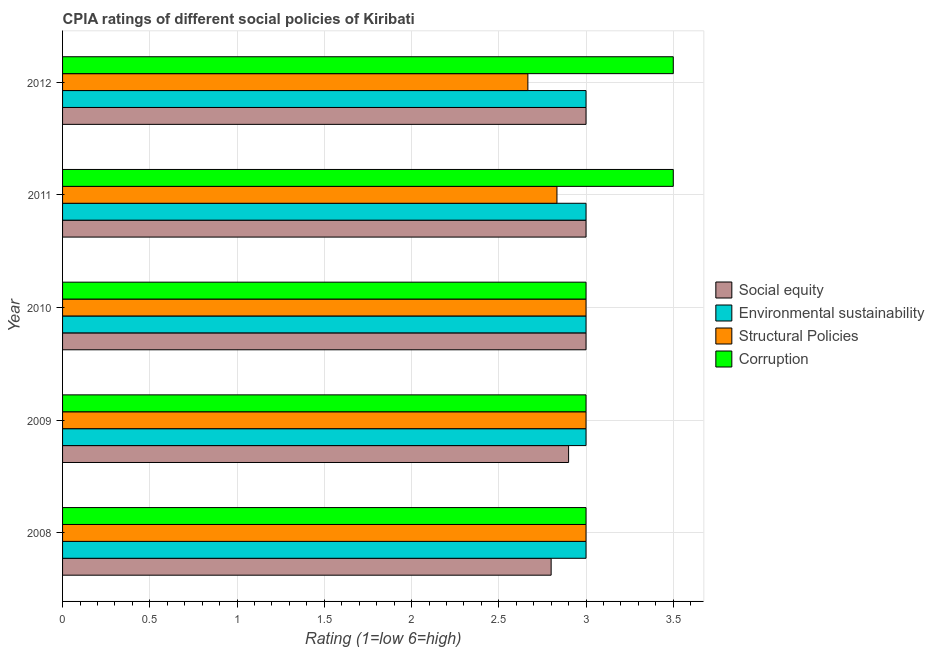How many different coloured bars are there?
Your response must be concise. 4. How many groups of bars are there?
Provide a succinct answer. 5. Are the number of bars per tick equal to the number of legend labels?
Keep it short and to the point. Yes. Are the number of bars on each tick of the Y-axis equal?
Provide a short and direct response. Yes. How many bars are there on the 2nd tick from the top?
Offer a terse response. 4. Across all years, what is the maximum cpia rating of environmental sustainability?
Your answer should be compact. 3. Across all years, what is the minimum cpia rating of structural policies?
Ensure brevity in your answer.  2.67. In which year was the cpia rating of structural policies maximum?
Provide a succinct answer. 2008. In which year was the cpia rating of corruption minimum?
Provide a short and direct response. 2008. What is the difference between the cpia rating of social equity in 2010 and the cpia rating of structural policies in 2009?
Ensure brevity in your answer.  0. In the year 2011, what is the difference between the cpia rating of environmental sustainability and cpia rating of structural policies?
Ensure brevity in your answer.  0.17. In how many years, is the cpia rating of social equity greater than 3.4 ?
Your answer should be compact. 0. What is the ratio of the cpia rating of social equity in 2009 to that in 2011?
Offer a very short reply. 0.97. Is the cpia rating of corruption in 2009 less than that in 2012?
Give a very brief answer. Yes. Is the difference between the cpia rating of structural policies in 2010 and 2012 greater than the difference between the cpia rating of corruption in 2010 and 2012?
Your answer should be compact. Yes. In how many years, is the cpia rating of corruption greater than the average cpia rating of corruption taken over all years?
Your answer should be very brief. 2. Is it the case that in every year, the sum of the cpia rating of environmental sustainability and cpia rating of structural policies is greater than the sum of cpia rating of corruption and cpia rating of social equity?
Make the answer very short. No. What does the 1st bar from the top in 2008 represents?
Offer a very short reply. Corruption. What does the 2nd bar from the bottom in 2012 represents?
Give a very brief answer. Environmental sustainability. Is it the case that in every year, the sum of the cpia rating of social equity and cpia rating of environmental sustainability is greater than the cpia rating of structural policies?
Offer a very short reply. Yes. How many bars are there?
Provide a short and direct response. 20. How many years are there in the graph?
Offer a terse response. 5. Are the values on the major ticks of X-axis written in scientific E-notation?
Offer a terse response. No. Where does the legend appear in the graph?
Give a very brief answer. Center right. What is the title of the graph?
Give a very brief answer. CPIA ratings of different social policies of Kiribati. Does "Services" appear as one of the legend labels in the graph?
Your answer should be compact. No. What is the label or title of the Y-axis?
Keep it short and to the point. Year. What is the Rating (1=low 6=high) in Environmental sustainability in 2008?
Offer a terse response. 3. What is the Rating (1=low 6=high) in Corruption in 2008?
Make the answer very short. 3. What is the Rating (1=low 6=high) of Social equity in 2009?
Provide a succinct answer. 2.9. What is the Rating (1=low 6=high) in Structural Policies in 2009?
Your response must be concise. 3. What is the Rating (1=low 6=high) in Corruption in 2009?
Keep it short and to the point. 3. What is the Rating (1=low 6=high) of Social equity in 2010?
Provide a succinct answer. 3. What is the Rating (1=low 6=high) in Structural Policies in 2010?
Provide a succinct answer. 3. What is the Rating (1=low 6=high) in Corruption in 2010?
Offer a terse response. 3. What is the Rating (1=low 6=high) in Social equity in 2011?
Give a very brief answer. 3. What is the Rating (1=low 6=high) in Structural Policies in 2011?
Provide a short and direct response. 2.83. What is the Rating (1=low 6=high) in Social equity in 2012?
Your response must be concise. 3. What is the Rating (1=low 6=high) in Structural Policies in 2012?
Offer a very short reply. 2.67. What is the Rating (1=low 6=high) of Corruption in 2012?
Your answer should be compact. 3.5. Across all years, what is the maximum Rating (1=low 6=high) of Social equity?
Provide a succinct answer. 3. Across all years, what is the maximum Rating (1=low 6=high) in Structural Policies?
Keep it short and to the point. 3. Across all years, what is the minimum Rating (1=low 6=high) in Social equity?
Your answer should be compact. 2.8. Across all years, what is the minimum Rating (1=low 6=high) in Structural Policies?
Your answer should be very brief. 2.67. Across all years, what is the minimum Rating (1=low 6=high) in Corruption?
Provide a short and direct response. 3. What is the total Rating (1=low 6=high) in Social equity in the graph?
Keep it short and to the point. 14.7. What is the total Rating (1=low 6=high) of Environmental sustainability in the graph?
Give a very brief answer. 15. What is the total Rating (1=low 6=high) in Corruption in the graph?
Ensure brevity in your answer.  16. What is the difference between the Rating (1=low 6=high) in Social equity in 2008 and that in 2009?
Provide a short and direct response. -0.1. What is the difference between the Rating (1=low 6=high) in Environmental sustainability in 2008 and that in 2009?
Provide a succinct answer. 0. What is the difference between the Rating (1=low 6=high) of Corruption in 2008 and that in 2009?
Your answer should be very brief. 0. What is the difference between the Rating (1=low 6=high) of Social equity in 2008 and that in 2010?
Offer a very short reply. -0.2. What is the difference between the Rating (1=low 6=high) in Social equity in 2008 and that in 2011?
Keep it short and to the point. -0.2. What is the difference between the Rating (1=low 6=high) of Structural Policies in 2008 and that in 2011?
Make the answer very short. 0.17. What is the difference between the Rating (1=low 6=high) in Corruption in 2008 and that in 2011?
Keep it short and to the point. -0.5. What is the difference between the Rating (1=low 6=high) in Environmental sustainability in 2008 and that in 2012?
Offer a very short reply. 0. What is the difference between the Rating (1=low 6=high) in Social equity in 2009 and that in 2010?
Offer a very short reply. -0.1. What is the difference between the Rating (1=low 6=high) of Environmental sustainability in 2009 and that in 2010?
Ensure brevity in your answer.  0. What is the difference between the Rating (1=low 6=high) in Structural Policies in 2009 and that in 2010?
Offer a terse response. 0. What is the difference between the Rating (1=low 6=high) of Structural Policies in 2009 and that in 2011?
Your response must be concise. 0.17. What is the difference between the Rating (1=low 6=high) of Social equity in 2009 and that in 2012?
Make the answer very short. -0.1. What is the difference between the Rating (1=low 6=high) in Social equity in 2010 and that in 2011?
Your answer should be compact. 0. What is the difference between the Rating (1=low 6=high) in Structural Policies in 2010 and that in 2011?
Make the answer very short. 0.17. What is the difference between the Rating (1=low 6=high) of Corruption in 2010 and that in 2011?
Give a very brief answer. -0.5. What is the difference between the Rating (1=low 6=high) of Environmental sustainability in 2010 and that in 2012?
Provide a short and direct response. 0. What is the difference between the Rating (1=low 6=high) in Corruption in 2010 and that in 2012?
Offer a terse response. -0.5. What is the difference between the Rating (1=low 6=high) in Corruption in 2011 and that in 2012?
Offer a terse response. 0. What is the difference between the Rating (1=low 6=high) of Social equity in 2008 and the Rating (1=low 6=high) of Structural Policies in 2009?
Keep it short and to the point. -0.2. What is the difference between the Rating (1=low 6=high) in Social equity in 2008 and the Rating (1=low 6=high) in Corruption in 2009?
Give a very brief answer. -0.2. What is the difference between the Rating (1=low 6=high) of Structural Policies in 2008 and the Rating (1=low 6=high) of Corruption in 2009?
Provide a succinct answer. 0. What is the difference between the Rating (1=low 6=high) in Social equity in 2008 and the Rating (1=low 6=high) in Environmental sustainability in 2010?
Your answer should be very brief. -0.2. What is the difference between the Rating (1=low 6=high) of Social equity in 2008 and the Rating (1=low 6=high) of Corruption in 2010?
Offer a terse response. -0.2. What is the difference between the Rating (1=low 6=high) in Environmental sustainability in 2008 and the Rating (1=low 6=high) in Structural Policies in 2010?
Make the answer very short. 0. What is the difference between the Rating (1=low 6=high) of Structural Policies in 2008 and the Rating (1=low 6=high) of Corruption in 2010?
Provide a short and direct response. 0. What is the difference between the Rating (1=low 6=high) of Social equity in 2008 and the Rating (1=low 6=high) of Environmental sustainability in 2011?
Make the answer very short. -0.2. What is the difference between the Rating (1=low 6=high) of Social equity in 2008 and the Rating (1=low 6=high) of Structural Policies in 2011?
Offer a very short reply. -0.03. What is the difference between the Rating (1=low 6=high) in Social equity in 2008 and the Rating (1=low 6=high) in Corruption in 2011?
Offer a terse response. -0.7. What is the difference between the Rating (1=low 6=high) in Environmental sustainability in 2008 and the Rating (1=low 6=high) in Structural Policies in 2011?
Make the answer very short. 0.17. What is the difference between the Rating (1=low 6=high) of Social equity in 2008 and the Rating (1=low 6=high) of Environmental sustainability in 2012?
Keep it short and to the point. -0.2. What is the difference between the Rating (1=low 6=high) of Social equity in 2008 and the Rating (1=low 6=high) of Structural Policies in 2012?
Ensure brevity in your answer.  0.13. What is the difference between the Rating (1=low 6=high) in Social equity in 2008 and the Rating (1=low 6=high) in Corruption in 2012?
Make the answer very short. -0.7. What is the difference between the Rating (1=low 6=high) of Structural Policies in 2008 and the Rating (1=low 6=high) of Corruption in 2012?
Offer a very short reply. -0.5. What is the difference between the Rating (1=low 6=high) in Social equity in 2009 and the Rating (1=low 6=high) in Environmental sustainability in 2010?
Make the answer very short. -0.1. What is the difference between the Rating (1=low 6=high) of Social equity in 2009 and the Rating (1=low 6=high) of Structural Policies in 2010?
Provide a succinct answer. -0.1. What is the difference between the Rating (1=low 6=high) of Social equity in 2009 and the Rating (1=low 6=high) of Corruption in 2010?
Offer a terse response. -0.1. What is the difference between the Rating (1=low 6=high) in Environmental sustainability in 2009 and the Rating (1=low 6=high) in Structural Policies in 2010?
Make the answer very short. 0. What is the difference between the Rating (1=low 6=high) of Social equity in 2009 and the Rating (1=low 6=high) of Environmental sustainability in 2011?
Ensure brevity in your answer.  -0.1. What is the difference between the Rating (1=low 6=high) of Social equity in 2009 and the Rating (1=low 6=high) of Structural Policies in 2011?
Keep it short and to the point. 0.07. What is the difference between the Rating (1=low 6=high) in Social equity in 2009 and the Rating (1=low 6=high) in Environmental sustainability in 2012?
Keep it short and to the point. -0.1. What is the difference between the Rating (1=low 6=high) of Social equity in 2009 and the Rating (1=low 6=high) of Structural Policies in 2012?
Ensure brevity in your answer.  0.23. What is the difference between the Rating (1=low 6=high) in Environmental sustainability in 2009 and the Rating (1=low 6=high) in Structural Policies in 2012?
Keep it short and to the point. 0.33. What is the difference between the Rating (1=low 6=high) in Environmental sustainability in 2009 and the Rating (1=low 6=high) in Corruption in 2012?
Your response must be concise. -0.5. What is the difference between the Rating (1=low 6=high) of Structural Policies in 2009 and the Rating (1=low 6=high) of Corruption in 2012?
Your answer should be compact. -0.5. What is the difference between the Rating (1=low 6=high) in Environmental sustainability in 2010 and the Rating (1=low 6=high) in Structural Policies in 2011?
Give a very brief answer. 0.17. What is the difference between the Rating (1=low 6=high) in Environmental sustainability in 2010 and the Rating (1=low 6=high) in Corruption in 2011?
Offer a very short reply. -0.5. What is the difference between the Rating (1=low 6=high) in Social equity in 2010 and the Rating (1=low 6=high) in Environmental sustainability in 2012?
Your answer should be very brief. 0. What is the difference between the Rating (1=low 6=high) in Environmental sustainability in 2010 and the Rating (1=low 6=high) in Structural Policies in 2012?
Your answer should be compact. 0.33. What is the difference between the Rating (1=low 6=high) in Environmental sustainability in 2010 and the Rating (1=low 6=high) in Corruption in 2012?
Provide a short and direct response. -0.5. What is the difference between the Rating (1=low 6=high) of Structural Policies in 2010 and the Rating (1=low 6=high) of Corruption in 2012?
Your answer should be very brief. -0.5. What is the difference between the Rating (1=low 6=high) in Social equity in 2011 and the Rating (1=low 6=high) in Structural Policies in 2012?
Ensure brevity in your answer.  0.33. What is the difference between the Rating (1=low 6=high) in Environmental sustainability in 2011 and the Rating (1=low 6=high) in Structural Policies in 2012?
Keep it short and to the point. 0.33. What is the difference between the Rating (1=low 6=high) in Structural Policies in 2011 and the Rating (1=low 6=high) in Corruption in 2012?
Provide a short and direct response. -0.67. What is the average Rating (1=low 6=high) in Social equity per year?
Keep it short and to the point. 2.94. In the year 2008, what is the difference between the Rating (1=low 6=high) in Social equity and Rating (1=low 6=high) in Structural Policies?
Offer a terse response. -0.2. In the year 2008, what is the difference between the Rating (1=low 6=high) of Social equity and Rating (1=low 6=high) of Corruption?
Keep it short and to the point. -0.2. In the year 2009, what is the difference between the Rating (1=low 6=high) of Environmental sustainability and Rating (1=low 6=high) of Structural Policies?
Your answer should be very brief. 0. In the year 2009, what is the difference between the Rating (1=low 6=high) of Structural Policies and Rating (1=low 6=high) of Corruption?
Provide a succinct answer. 0. In the year 2010, what is the difference between the Rating (1=low 6=high) of Social equity and Rating (1=low 6=high) of Structural Policies?
Keep it short and to the point. 0. In the year 2010, what is the difference between the Rating (1=low 6=high) of Environmental sustainability and Rating (1=low 6=high) of Structural Policies?
Offer a very short reply. 0. In the year 2010, what is the difference between the Rating (1=low 6=high) in Structural Policies and Rating (1=low 6=high) in Corruption?
Make the answer very short. 0. In the year 2011, what is the difference between the Rating (1=low 6=high) in Social equity and Rating (1=low 6=high) in Environmental sustainability?
Ensure brevity in your answer.  0. In the year 2011, what is the difference between the Rating (1=low 6=high) of Social equity and Rating (1=low 6=high) of Structural Policies?
Your answer should be very brief. 0.17. In the year 2011, what is the difference between the Rating (1=low 6=high) of Environmental sustainability and Rating (1=low 6=high) of Structural Policies?
Provide a succinct answer. 0.17. In the year 2012, what is the difference between the Rating (1=low 6=high) in Social equity and Rating (1=low 6=high) in Environmental sustainability?
Offer a terse response. 0. In the year 2012, what is the difference between the Rating (1=low 6=high) of Social equity and Rating (1=low 6=high) of Structural Policies?
Provide a short and direct response. 0.33. In the year 2012, what is the difference between the Rating (1=low 6=high) of Social equity and Rating (1=low 6=high) of Corruption?
Keep it short and to the point. -0.5. In the year 2012, what is the difference between the Rating (1=low 6=high) of Environmental sustainability and Rating (1=low 6=high) of Structural Policies?
Keep it short and to the point. 0.33. In the year 2012, what is the difference between the Rating (1=low 6=high) in Structural Policies and Rating (1=low 6=high) in Corruption?
Your response must be concise. -0.83. What is the ratio of the Rating (1=low 6=high) in Social equity in 2008 to that in 2009?
Your answer should be very brief. 0.97. What is the ratio of the Rating (1=low 6=high) of Environmental sustainability in 2008 to that in 2009?
Give a very brief answer. 1. What is the ratio of the Rating (1=low 6=high) of Corruption in 2008 to that in 2009?
Make the answer very short. 1. What is the ratio of the Rating (1=low 6=high) in Environmental sustainability in 2008 to that in 2010?
Offer a very short reply. 1. What is the ratio of the Rating (1=low 6=high) of Environmental sustainability in 2008 to that in 2011?
Your response must be concise. 1. What is the ratio of the Rating (1=low 6=high) of Structural Policies in 2008 to that in 2011?
Provide a succinct answer. 1.06. What is the ratio of the Rating (1=low 6=high) in Corruption in 2008 to that in 2011?
Ensure brevity in your answer.  0.86. What is the ratio of the Rating (1=low 6=high) in Social equity in 2008 to that in 2012?
Make the answer very short. 0.93. What is the ratio of the Rating (1=low 6=high) in Corruption in 2008 to that in 2012?
Make the answer very short. 0.86. What is the ratio of the Rating (1=low 6=high) in Social equity in 2009 to that in 2010?
Keep it short and to the point. 0.97. What is the ratio of the Rating (1=low 6=high) in Structural Policies in 2009 to that in 2010?
Make the answer very short. 1. What is the ratio of the Rating (1=low 6=high) of Corruption in 2009 to that in 2010?
Your answer should be compact. 1. What is the ratio of the Rating (1=low 6=high) of Social equity in 2009 to that in 2011?
Provide a succinct answer. 0.97. What is the ratio of the Rating (1=low 6=high) in Environmental sustainability in 2009 to that in 2011?
Your answer should be compact. 1. What is the ratio of the Rating (1=low 6=high) in Structural Policies in 2009 to that in 2011?
Your answer should be very brief. 1.06. What is the ratio of the Rating (1=low 6=high) of Corruption in 2009 to that in 2011?
Provide a short and direct response. 0.86. What is the ratio of the Rating (1=low 6=high) in Social equity in 2009 to that in 2012?
Give a very brief answer. 0.97. What is the ratio of the Rating (1=low 6=high) in Social equity in 2010 to that in 2011?
Offer a terse response. 1. What is the ratio of the Rating (1=low 6=high) in Environmental sustainability in 2010 to that in 2011?
Give a very brief answer. 1. What is the ratio of the Rating (1=low 6=high) of Structural Policies in 2010 to that in 2011?
Your answer should be compact. 1.06. What is the ratio of the Rating (1=low 6=high) of Corruption in 2010 to that in 2011?
Keep it short and to the point. 0.86. What is the ratio of the Rating (1=low 6=high) of Social equity in 2010 to that in 2012?
Offer a terse response. 1. What is the ratio of the Rating (1=low 6=high) in Environmental sustainability in 2010 to that in 2012?
Provide a succinct answer. 1. What is the ratio of the Rating (1=low 6=high) in Structural Policies in 2010 to that in 2012?
Your answer should be very brief. 1.12. What is the ratio of the Rating (1=low 6=high) of Corruption in 2010 to that in 2012?
Provide a succinct answer. 0.86. What is the ratio of the Rating (1=low 6=high) in Social equity in 2011 to that in 2012?
Offer a very short reply. 1. What is the ratio of the Rating (1=low 6=high) of Environmental sustainability in 2011 to that in 2012?
Your response must be concise. 1. What is the ratio of the Rating (1=low 6=high) in Structural Policies in 2011 to that in 2012?
Your answer should be very brief. 1.06. What is the difference between the highest and the second highest Rating (1=low 6=high) of Social equity?
Keep it short and to the point. 0. What is the difference between the highest and the second highest Rating (1=low 6=high) in Environmental sustainability?
Your answer should be compact. 0. What is the difference between the highest and the second highest Rating (1=low 6=high) in Corruption?
Your response must be concise. 0. What is the difference between the highest and the lowest Rating (1=low 6=high) in Environmental sustainability?
Provide a short and direct response. 0. What is the difference between the highest and the lowest Rating (1=low 6=high) of Corruption?
Offer a terse response. 0.5. 